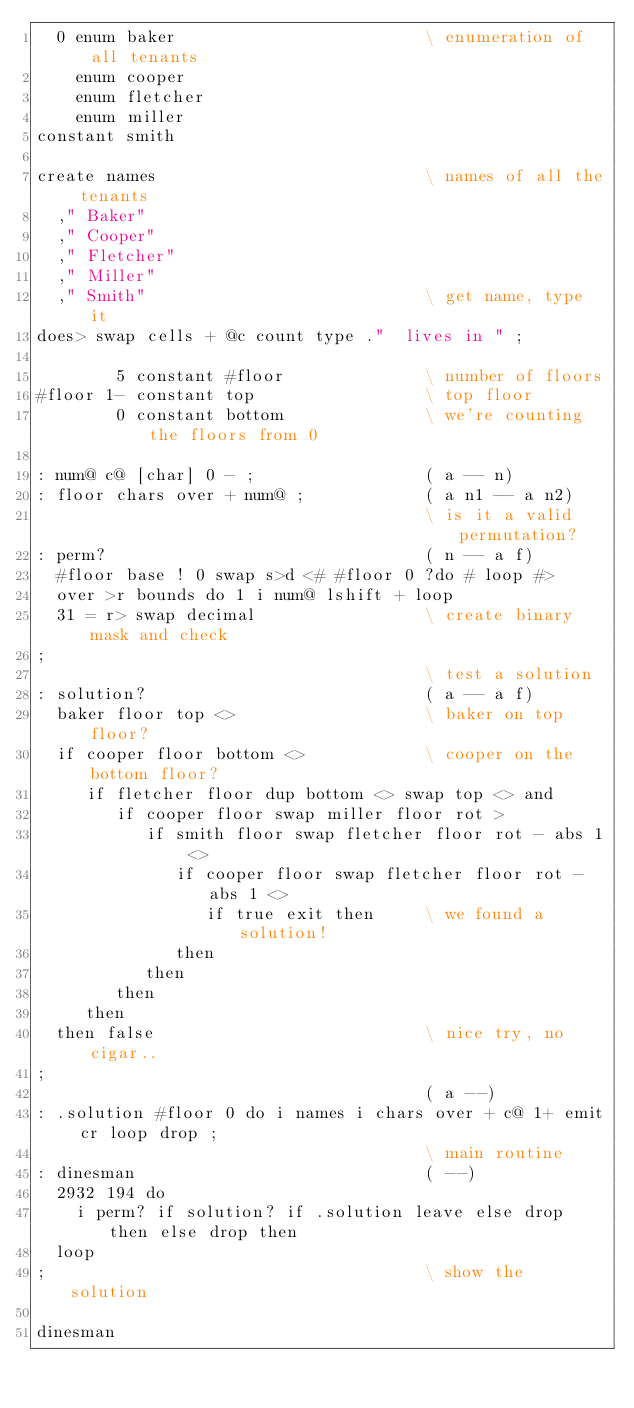Convert code to text. <code><loc_0><loc_0><loc_500><loc_500><_Forth_>  0 enum baker                         \ enumeration of all tenants
    enum cooper
    enum fletcher
    enum miller
constant smith

create names                           \ names of all the tenants
  ," Baker"
  ," Cooper"
  ," Fletcher"
  ," Miller"
  ," Smith"                            \ get name, type it
does> swap cells + @c count type ."  lives in " ;

        5 constant #floor              \ number of floors
#floor 1- constant top                 \ top floor
        0 constant bottom              \ we're counting the floors from 0

: num@ c@ [char] 0 - ;                 ( a -- n)
: floor chars over + num@ ;            ( a n1 -- a n2)
                                       \ is it a valid permutation?
: perm?                                ( n -- a f)
  #floor base ! 0 swap s>d <# #floor 0 ?do # loop #>
  over >r bounds do 1 i num@ lshift + loop
  31 = r> swap decimal                 \ create binary mask and check
;
                                       \ test a solution
: solution?                            ( a -- a f)
  baker floor top <>                   \ baker on top floor?
  if cooper floor bottom <>            \ cooper on the bottom floor?
     if fletcher floor dup bottom <> swap top <> and
        if cooper floor swap miller floor rot >
           if smith floor swap fletcher floor rot - abs 1 <>
              if cooper floor swap fletcher floor rot - abs 1 <>
                 if true exit then     \ we found a solution!
              then
           then
        then
     then
  then false                           \ nice try, no cigar..
;
                                       ( a --)
: .solution #floor 0 do i names i chars over + c@ 1+ emit cr loop drop ;
                                       \ main routine
: dinesman                             ( --)
  2932 194 do
    i perm? if solution? if .solution leave else drop then else drop then
  loop
;                                      \ show the solution

dinesman
</code> 